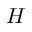<formula> <loc_0><loc_0><loc_500><loc_500>H</formula> 